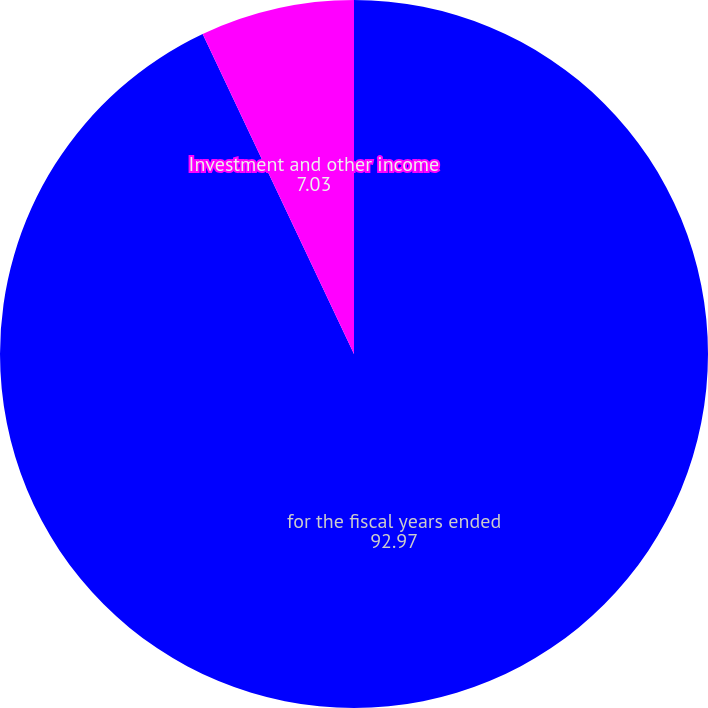Convert chart. <chart><loc_0><loc_0><loc_500><loc_500><pie_chart><fcel>for the fiscal years ended<fcel>Investment and other income<nl><fcel>92.97%<fcel>7.03%<nl></chart> 